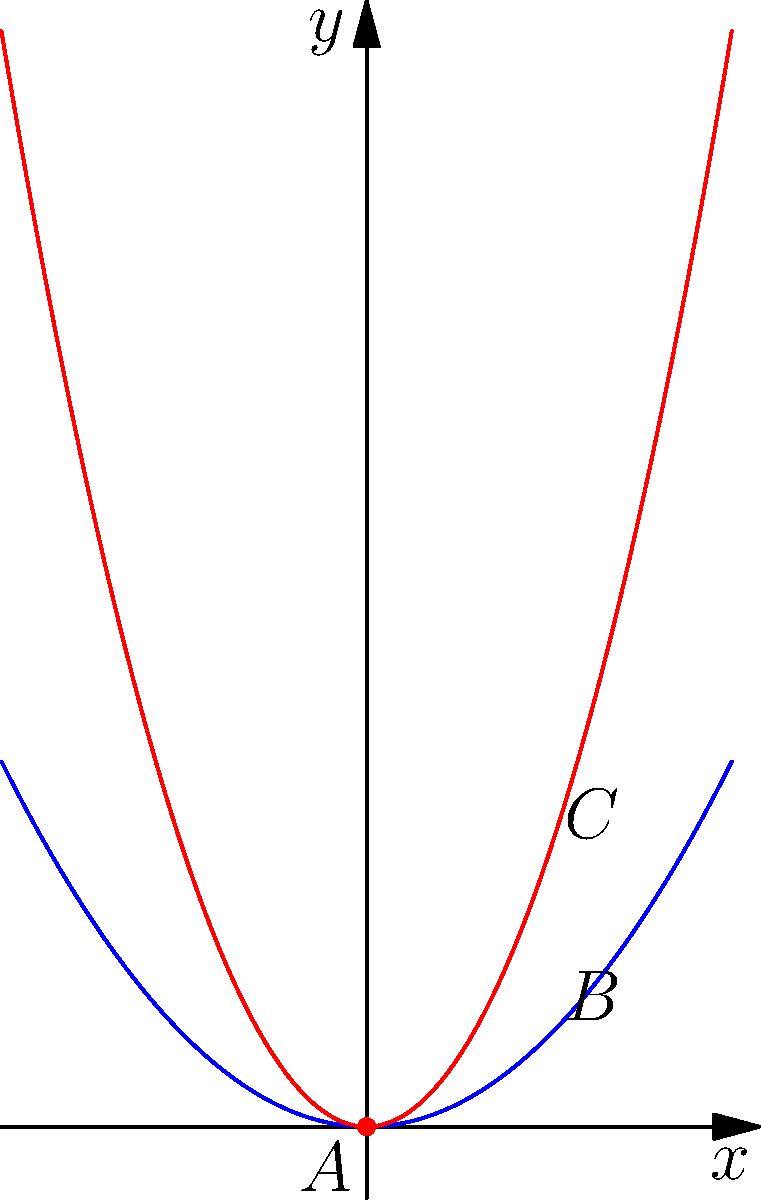A sculptor is creating a smooth, curved rock surface. The surface can be modeled by two functions: $f(x) = 0.5x^2$ (blue curve) and $g(x) = 1.5x^2$ (red curve). Calculate the difference in curvature between points B and C, located at $x=1$ on their respective curves. To solve this problem, we'll follow these steps:

1) The curvature $\kappa$ of a function $y = h(x)$ at any point is given by:

   $$\kappa = \frac{|h''(x)|}{(1 + (h'(x))^2)^{3/2}}$$

2) For $f(x) = 0.5x^2$:
   $f'(x) = x$
   $f''(x) = 1$

3) For $g(x) = 1.5x^2$:
   $g'(x) = 3x$
   $g''(x) = 3$

4) At point B $(x=1)$ on $f(x)$:
   $$\kappa_B = \frac{|1|}{(1 + (1)^2)^{3/2}} = \frac{1}{2\sqrt{2}} \approx 0.3536$$

5) At point C $(x=1)$ on $g(x)$:
   $$\kappa_C = \frac{|3|}{(1 + (3)^2)^{3/2}} = \frac{3}{10\sqrt{10}} \approx 0.2683$$

6) The difference in curvature:
   $$\Delta\kappa = \kappa_B - \kappa_C = \frac{1}{2\sqrt{2}} - \frac{3}{10\sqrt{10}} \approx 0.0853$$
Answer: $\frac{1}{2\sqrt{2}} - \frac{3}{10\sqrt{10}}$ 